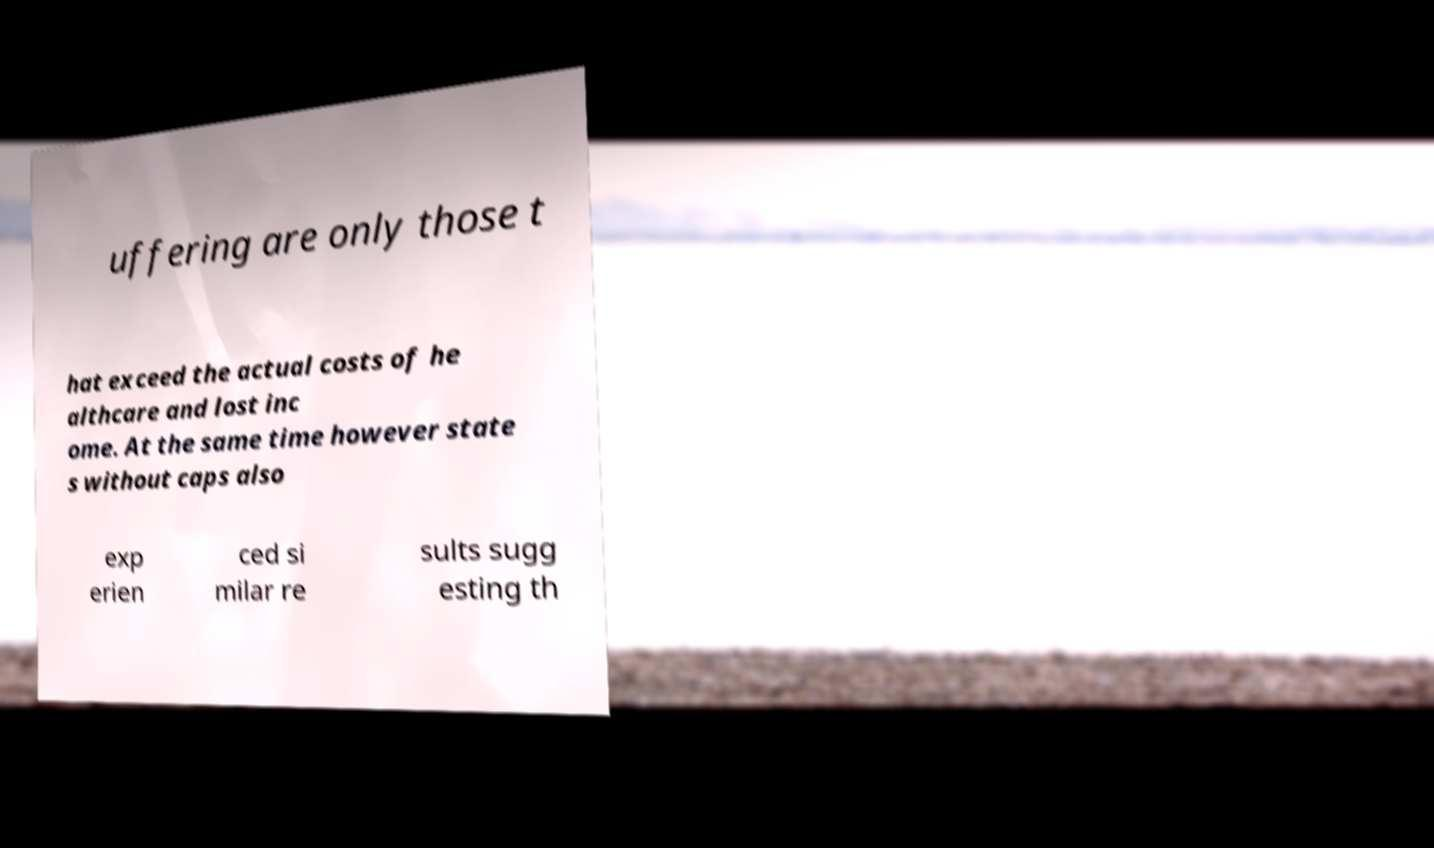Could you extract and type out the text from this image? uffering are only those t hat exceed the actual costs of he althcare and lost inc ome. At the same time however state s without caps also exp erien ced si milar re sults sugg esting th 